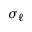Convert formula to latex. <formula><loc_0><loc_0><loc_500><loc_500>\sigma _ { \ell }</formula> 